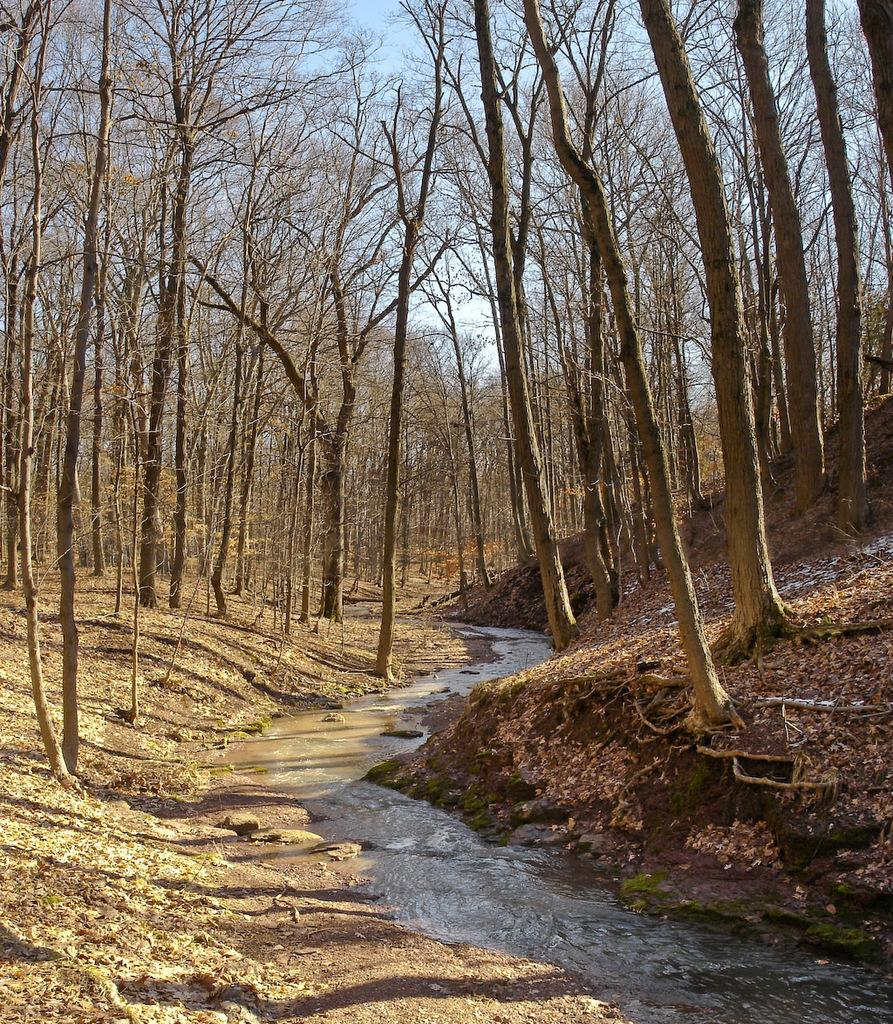What type of vegetation can be seen in the image? There are trees in the image. What part of the trees can be seen in the image? There are branches in the image. What type of terrain is visible in the image? There is land visible in the image. What type of natural feature can be seen in the image? There are waterstones in the image. What is visible in the background of the image? The sky is visible in the image. Can you tell me how many visitors have approved the liquid in the image? There are no visitors or liquid present in the image. What type of creature is shown interacting with the waterstones in the image? There is no creature shown interacting with the waterstones in the image; only the trees, branches, land, waterstones, and sky are present. 